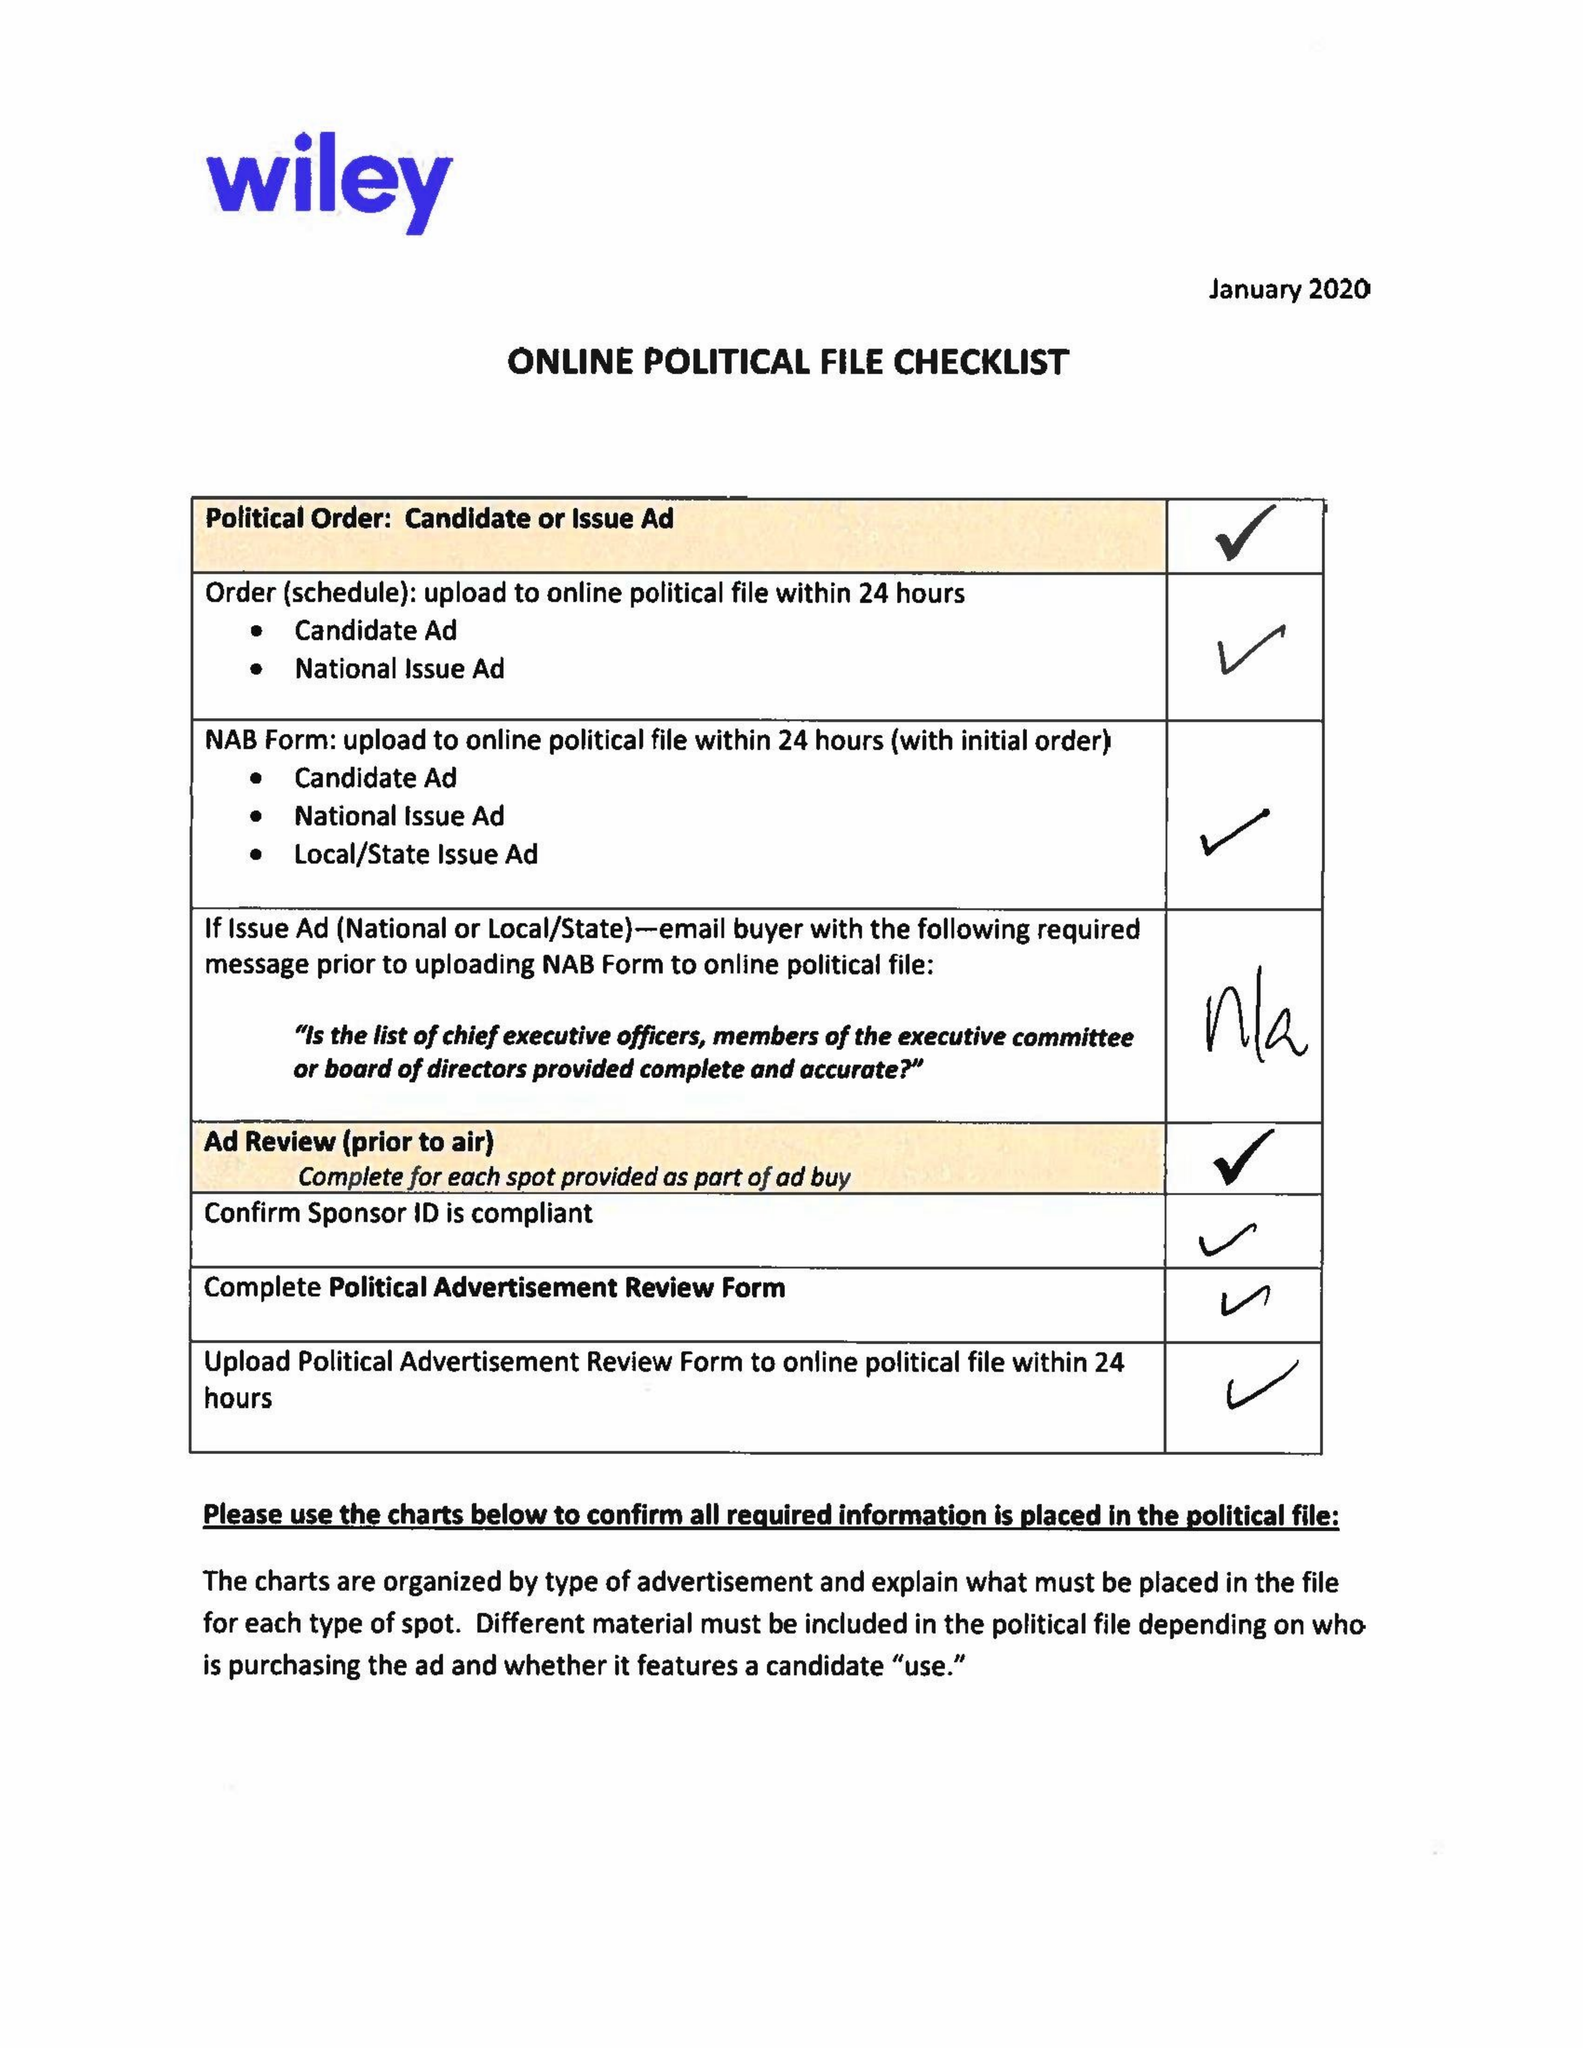What is the value for the flight_from?
Answer the question using a single word or phrase. 02/10/20 